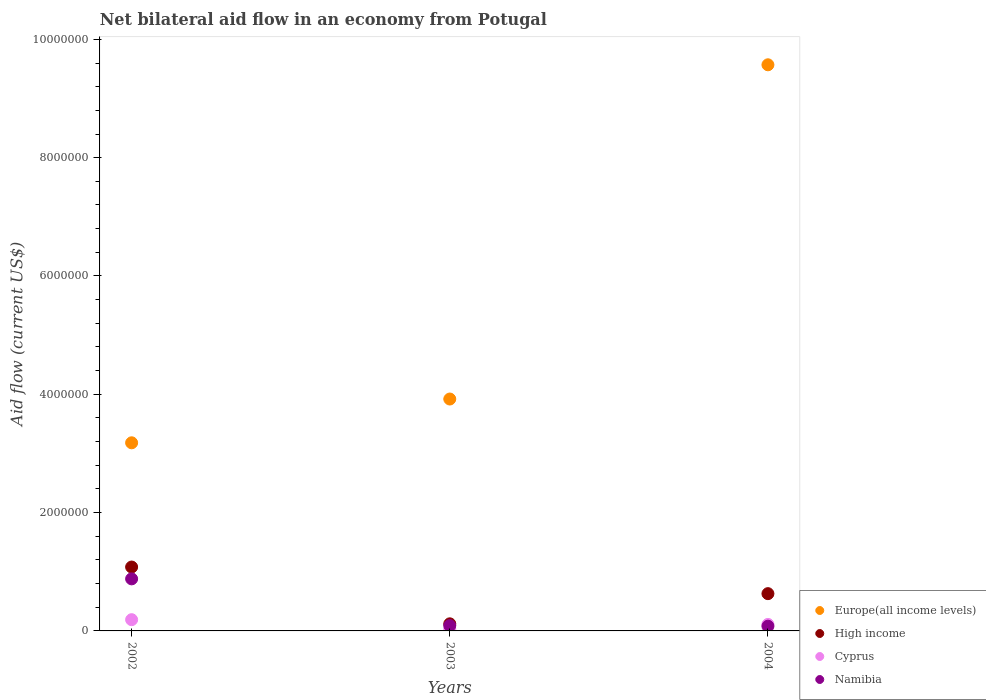How many different coloured dotlines are there?
Make the answer very short. 4. Across all years, what is the maximum net bilateral aid flow in Namibia?
Give a very brief answer. 8.80e+05. Across all years, what is the minimum net bilateral aid flow in Namibia?
Your answer should be compact. 8.00e+04. In which year was the net bilateral aid flow in Namibia maximum?
Keep it short and to the point. 2002. What is the total net bilateral aid flow in High income in the graph?
Provide a succinct answer. 1.83e+06. What is the difference between the net bilateral aid flow in Europe(all income levels) in 2004 and the net bilateral aid flow in High income in 2002?
Your response must be concise. 8.49e+06. What is the average net bilateral aid flow in Cyprus per year?
Provide a succinct answer. 1.10e+05. In the year 2002, what is the difference between the net bilateral aid flow in Europe(all income levels) and net bilateral aid flow in High income?
Your answer should be very brief. 2.10e+06. In how many years, is the net bilateral aid flow in Namibia greater than 9600000 US$?
Make the answer very short. 0. What is the ratio of the net bilateral aid flow in High income in 2002 to that in 2004?
Provide a short and direct response. 1.71. Is the net bilateral aid flow in High income in 2002 less than that in 2004?
Give a very brief answer. No. Is the difference between the net bilateral aid flow in Europe(all income levels) in 2002 and 2004 greater than the difference between the net bilateral aid flow in High income in 2002 and 2004?
Give a very brief answer. No. What is the difference between the highest and the second highest net bilateral aid flow in Namibia?
Your answer should be very brief. 7.90e+05. What is the difference between the highest and the lowest net bilateral aid flow in Europe(all income levels)?
Your answer should be very brief. 6.39e+06. In how many years, is the net bilateral aid flow in Namibia greater than the average net bilateral aid flow in Namibia taken over all years?
Keep it short and to the point. 1. Is it the case that in every year, the sum of the net bilateral aid flow in High income and net bilateral aid flow in Namibia  is greater than the net bilateral aid flow in Europe(all income levels)?
Offer a very short reply. No. Does the net bilateral aid flow in Namibia monotonically increase over the years?
Provide a succinct answer. No. Is the net bilateral aid flow in Europe(all income levels) strictly greater than the net bilateral aid flow in Cyprus over the years?
Offer a terse response. Yes. How many years are there in the graph?
Keep it short and to the point. 3. What is the difference between two consecutive major ticks on the Y-axis?
Give a very brief answer. 2.00e+06. Does the graph contain any zero values?
Offer a terse response. No. How many legend labels are there?
Make the answer very short. 4. What is the title of the graph?
Make the answer very short. Net bilateral aid flow in an economy from Potugal. What is the label or title of the Y-axis?
Your response must be concise. Aid flow (current US$). What is the Aid flow (current US$) of Europe(all income levels) in 2002?
Ensure brevity in your answer.  3.18e+06. What is the Aid flow (current US$) in High income in 2002?
Your answer should be compact. 1.08e+06. What is the Aid flow (current US$) in Cyprus in 2002?
Offer a terse response. 1.90e+05. What is the Aid flow (current US$) of Namibia in 2002?
Provide a short and direct response. 8.80e+05. What is the Aid flow (current US$) of Europe(all income levels) in 2003?
Keep it short and to the point. 3.92e+06. What is the Aid flow (current US$) in Cyprus in 2003?
Make the answer very short. 3.00e+04. What is the Aid flow (current US$) of Namibia in 2003?
Your answer should be compact. 9.00e+04. What is the Aid flow (current US$) in Europe(all income levels) in 2004?
Keep it short and to the point. 9.57e+06. What is the Aid flow (current US$) in High income in 2004?
Ensure brevity in your answer.  6.30e+05. What is the Aid flow (current US$) of Cyprus in 2004?
Your answer should be compact. 1.10e+05. Across all years, what is the maximum Aid flow (current US$) of Europe(all income levels)?
Keep it short and to the point. 9.57e+06. Across all years, what is the maximum Aid flow (current US$) in High income?
Keep it short and to the point. 1.08e+06. Across all years, what is the maximum Aid flow (current US$) of Cyprus?
Provide a short and direct response. 1.90e+05. Across all years, what is the maximum Aid flow (current US$) of Namibia?
Make the answer very short. 8.80e+05. Across all years, what is the minimum Aid flow (current US$) of Europe(all income levels)?
Provide a short and direct response. 3.18e+06. Across all years, what is the minimum Aid flow (current US$) of High income?
Keep it short and to the point. 1.20e+05. What is the total Aid flow (current US$) in Europe(all income levels) in the graph?
Keep it short and to the point. 1.67e+07. What is the total Aid flow (current US$) of High income in the graph?
Your response must be concise. 1.83e+06. What is the total Aid flow (current US$) of Cyprus in the graph?
Provide a short and direct response. 3.30e+05. What is the total Aid flow (current US$) in Namibia in the graph?
Keep it short and to the point. 1.05e+06. What is the difference between the Aid flow (current US$) in Europe(all income levels) in 2002 and that in 2003?
Offer a terse response. -7.40e+05. What is the difference between the Aid flow (current US$) of High income in 2002 and that in 2003?
Give a very brief answer. 9.60e+05. What is the difference between the Aid flow (current US$) of Cyprus in 2002 and that in 2003?
Provide a short and direct response. 1.60e+05. What is the difference between the Aid flow (current US$) of Namibia in 2002 and that in 2003?
Offer a terse response. 7.90e+05. What is the difference between the Aid flow (current US$) of Europe(all income levels) in 2002 and that in 2004?
Make the answer very short. -6.39e+06. What is the difference between the Aid flow (current US$) in High income in 2002 and that in 2004?
Offer a terse response. 4.50e+05. What is the difference between the Aid flow (current US$) in Europe(all income levels) in 2003 and that in 2004?
Provide a succinct answer. -5.65e+06. What is the difference between the Aid flow (current US$) in High income in 2003 and that in 2004?
Your answer should be very brief. -5.10e+05. What is the difference between the Aid flow (current US$) in Cyprus in 2003 and that in 2004?
Make the answer very short. -8.00e+04. What is the difference between the Aid flow (current US$) in Namibia in 2003 and that in 2004?
Your response must be concise. 10000. What is the difference between the Aid flow (current US$) of Europe(all income levels) in 2002 and the Aid flow (current US$) of High income in 2003?
Keep it short and to the point. 3.06e+06. What is the difference between the Aid flow (current US$) of Europe(all income levels) in 2002 and the Aid flow (current US$) of Cyprus in 2003?
Ensure brevity in your answer.  3.15e+06. What is the difference between the Aid flow (current US$) in Europe(all income levels) in 2002 and the Aid flow (current US$) in Namibia in 2003?
Keep it short and to the point. 3.09e+06. What is the difference between the Aid flow (current US$) in High income in 2002 and the Aid flow (current US$) in Cyprus in 2003?
Offer a very short reply. 1.05e+06. What is the difference between the Aid flow (current US$) of High income in 2002 and the Aid flow (current US$) of Namibia in 2003?
Ensure brevity in your answer.  9.90e+05. What is the difference between the Aid flow (current US$) of Europe(all income levels) in 2002 and the Aid flow (current US$) of High income in 2004?
Your answer should be compact. 2.55e+06. What is the difference between the Aid flow (current US$) in Europe(all income levels) in 2002 and the Aid flow (current US$) in Cyprus in 2004?
Your answer should be very brief. 3.07e+06. What is the difference between the Aid flow (current US$) in Europe(all income levels) in 2002 and the Aid flow (current US$) in Namibia in 2004?
Your answer should be compact. 3.10e+06. What is the difference between the Aid flow (current US$) in High income in 2002 and the Aid flow (current US$) in Cyprus in 2004?
Your response must be concise. 9.70e+05. What is the difference between the Aid flow (current US$) of Europe(all income levels) in 2003 and the Aid flow (current US$) of High income in 2004?
Make the answer very short. 3.29e+06. What is the difference between the Aid flow (current US$) in Europe(all income levels) in 2003 and the Aid flow (current US$) in Cyprus in 2004?
Keep it short and to the point. 3.81e+06. What is the difference between the Aid flow (current US$) in Europe(all income levels) in 2003 and the Aid flow (current US$) in Namibia in 2004?
Provide a succinct answer. 3.84e+06. What is the difference between the Aid flow (current US$) of High income in 2003 and the Aid flow (current US$) of Cyprus in 2004?
Your answer should be very brief. 10000. What is the average Aid flow (current US$) in Europe(all income levels) per year?
Give a very brief answer. 5.56e+06. What is the average Aid flow (current US$) of High income per year?
Offer a very short reply. 6.10e+05. What is the average Aid flow (current US$) in Namibia per year?
Offer a terse response. 3.50e+05. In the year 2002, what is the difference between the Aid flow (current US$) in Europe(all income levels) and Aid flow (current US$) in High income?
Give a very brief answer. 2.10e+06. In the year 2002, what is the difference between the Aid flow (current US$) in Europe(all income levels) and Aid flow (current US$) in Cyprus?
Ensure brevity in your answer.  2.99e+06. In the year 2002, what is the difference between the Aid flow (current US$) of Europe(all income levels) and Aid flow (current US$) of Namibia?
Your answer should be very brief. 2.30e+06. In the year 2002, what is the difference between the Aid flow (current US$) in High income and Aid flow (current US$) in Cyprus?
Your answer should be very brief. 8.90e+05. In the year 2002, what is the difference between the Aid flow (current US$) in Cyprus and Aid flow (current US$) in Namibia?
Your answer should be very brief. -6.90e+05. In the year 2003, what is the difference between the Aid flow (current US$) in Europe(all income levels) and Aid flow (current US$) in High income?
Offer a terse response. 3.80e+06. In the year 2003, what is the difference between the Aid flow (current US$) of Europe(all income levels) and Aid flow (current US$) of Cyprus?
Provide a succinct answer. 3.89e+06. In the year 2003, what is the difference between the Aid flow (current US$) of Europe(all income levels) and Aid flow (current US$) of Namibia?
Your answer should be very brief. 3.83e+06. In the year 2003, what is the difference between the Aid flow (current US$) in High income and Aid flow (current US$) in Namibia?
Your answer should be very brief. 3.00e+04. In the year 2004, what is the difference between the Aid flow (current US$) of Europe(all income levels) and Aid flow (current US$) of High income?
Provide a succinct answer. 8.94e+06. In the year 2004, what is the difference between the Aid flow (current US$) in Europe(all income levels) and Aid flow (current US$) in Cyprus?
Give a very brief answer. 9.46e+06. In the year 2004, what is the difference between the Aid flow (current US$) of Europe(all income levels) and Aid flow (current US$) of Namibia?
Your answer should be compact. 9.49e+06. In the year 2004, what is the difference between the Aid flow (current US$) of High income and Aid flow (current US$) of Cyprus?
Provide a short and direct response. 5.20e+05. What is the ratio of the Aid flow (current US$) of Europe(all income levels) in 2002 to that in 2003?
Keep it short and to the point. 0.81. What is the ratio of the Aid flow (current US$) in Cyprus in 2002 to that in 2003?
Make the answer very short. 6.33. What is the ratio of the Aid flow (current US$) in Namibia in 2002 to that in 2003?
Give a very brief answer. 9.78. What is the ratio of the Aid flow (current US$) of Europe(all income levels) in 2002 to that in 2004?
Your answer should be very brief. 0.33. What is the ratio of the Aid flow (current US$) in High income in 2002 to that in 2004?
Keep it short and to the point. 1.71. What is the ratio of the Aid flow (current US$) of Cyprus in 2002 to that in 2004?
Provide a succinct answer. 1.73. What is the ratio of the Aid flow (current US$) in Namibia in 2002 to that in 2004?
Your answer should be very brief. 11. What is the ratio of the Aid flow (current US$) of Europe(all income levels) in 2003 to that in 2004?
Your answer should be very brief. 0.41. What is the ratio of the Aid flow (current US$) in High income in 2003 to that in 2004?
Your response must be concise. 0.19. What is the ratio of the Aid flow (current US$) in Cyprus in 2003 to that in 2004?
Provide a short and direct response. 0.27. What is the difference between the highest and the second highest Aid flow (current US$) in Europe(all income levels)?
Make the answer very short. 5.65e+06. What is the difference between the highest and the second highest Aid flow (current US$) in High income?
Your response must be concise. 4.50e+05. What is the difference between the highest and the second highest Aid flow (current US$) in Namibia?
Make the answer very short. 7.90e+05. What is the difference between the highest and the lowest Aid flow (current US$) of Europe(all income levels)?
Your answer should be compact. 6.39e+06. What is the difference between the highest and the lowest Aid flow (current US$) of High income?
Your answer should be compact. 9.60e+05. What is the difference between the highest and the lowest Aid flow (current US$) of Cyprus?
Ensure brevity in your answer.  1.60e+05. 